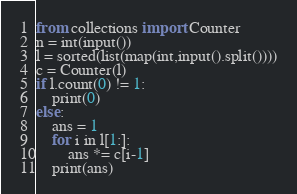Convert code to text. <code><loc_0><loc_0><loc_500><loc_500><_Python_>from collections import Counter
n = int(input())
l = sorted(list(map(int,input().split())))
c = Counter(l)
if l.count(0) != 1:
    print(0)
else:
    ans = 1
    for i in l[1:]:
        ans *= c[i-1]
    print(ans)</code> 